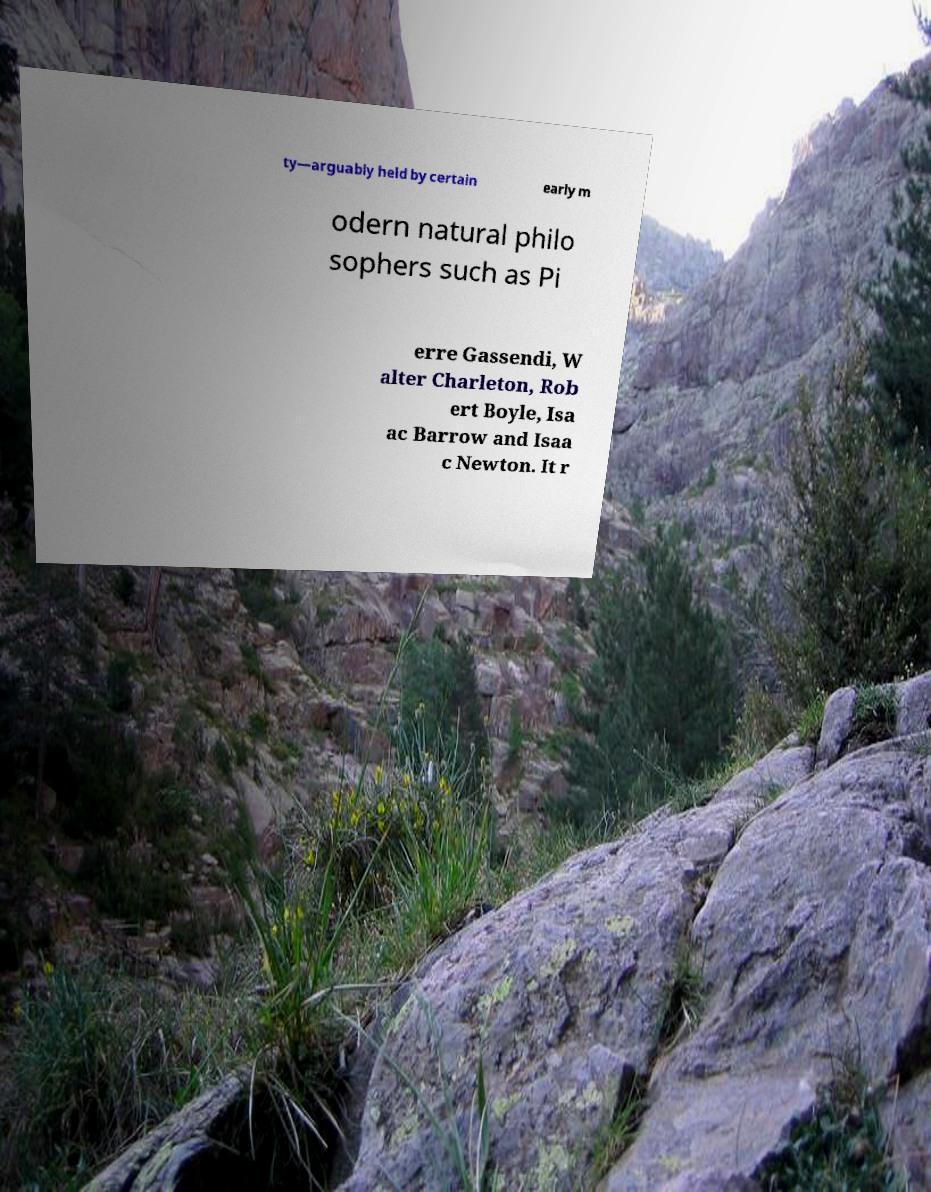Can you accurately transcribe the text from the provided image for me? ty—arguably held by certain early m odern natural philo sophers such as Pi erre Gassendi, W alter Charleton, Rob ert Boyle, Isa ac Barrow and Isaa c Newton. It r 